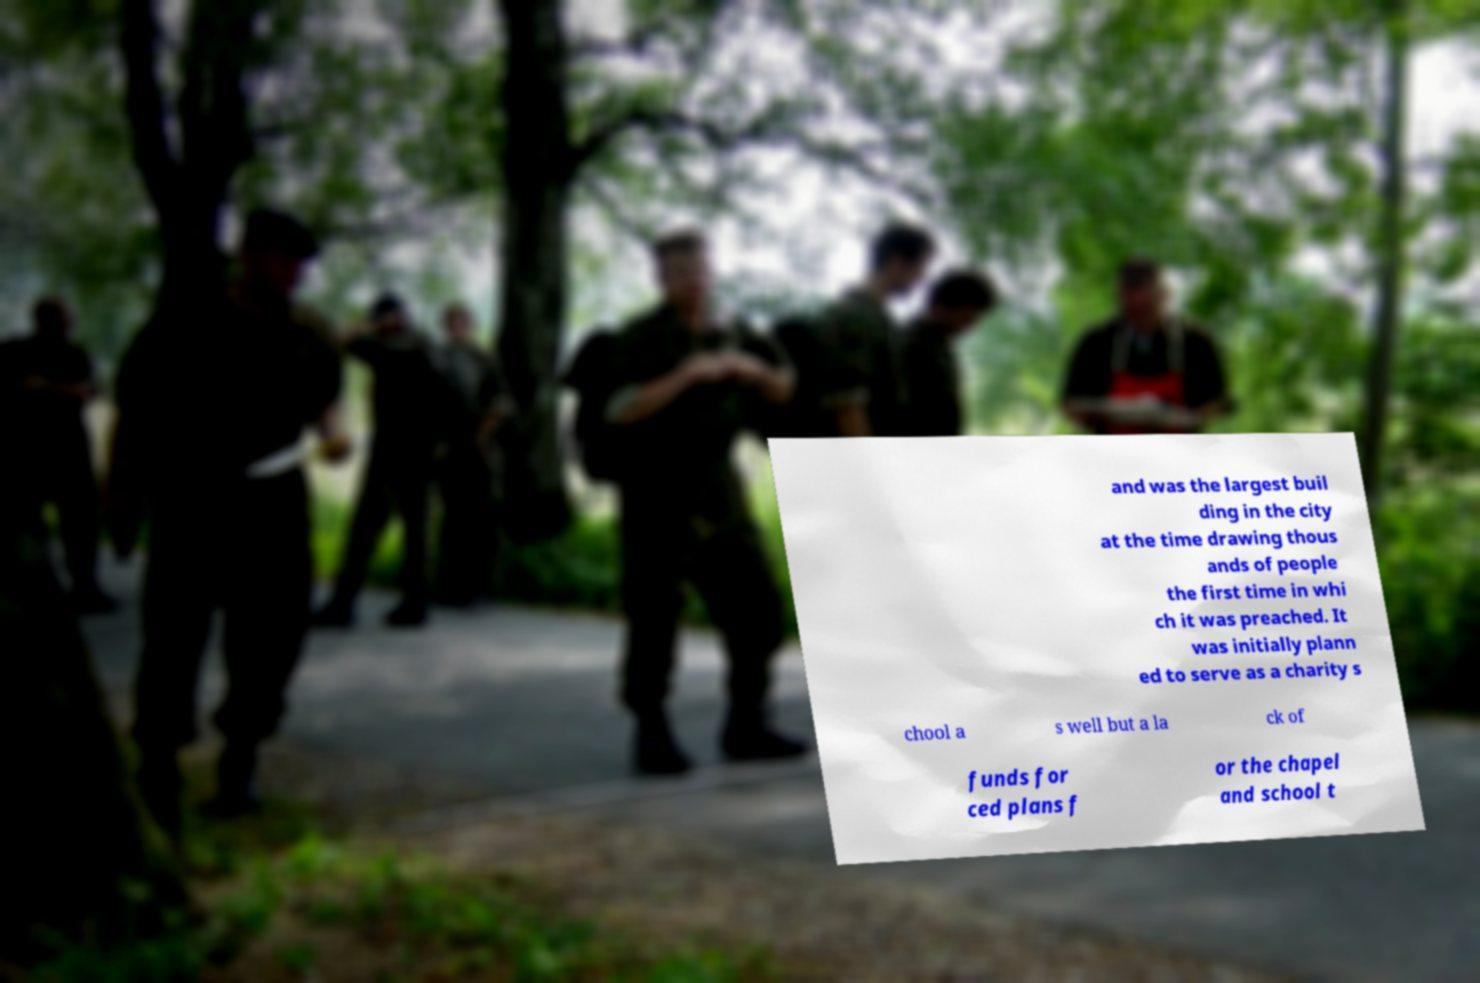Could you extract and type out the text from this image? and was the largest buil ding in the city at the time drawing thous ands of people the first time in whi ch it was preached. It was initially plann ed to serve as a charity s chool a s well but a la ck of funds for ced plans f or the chapel and school t 